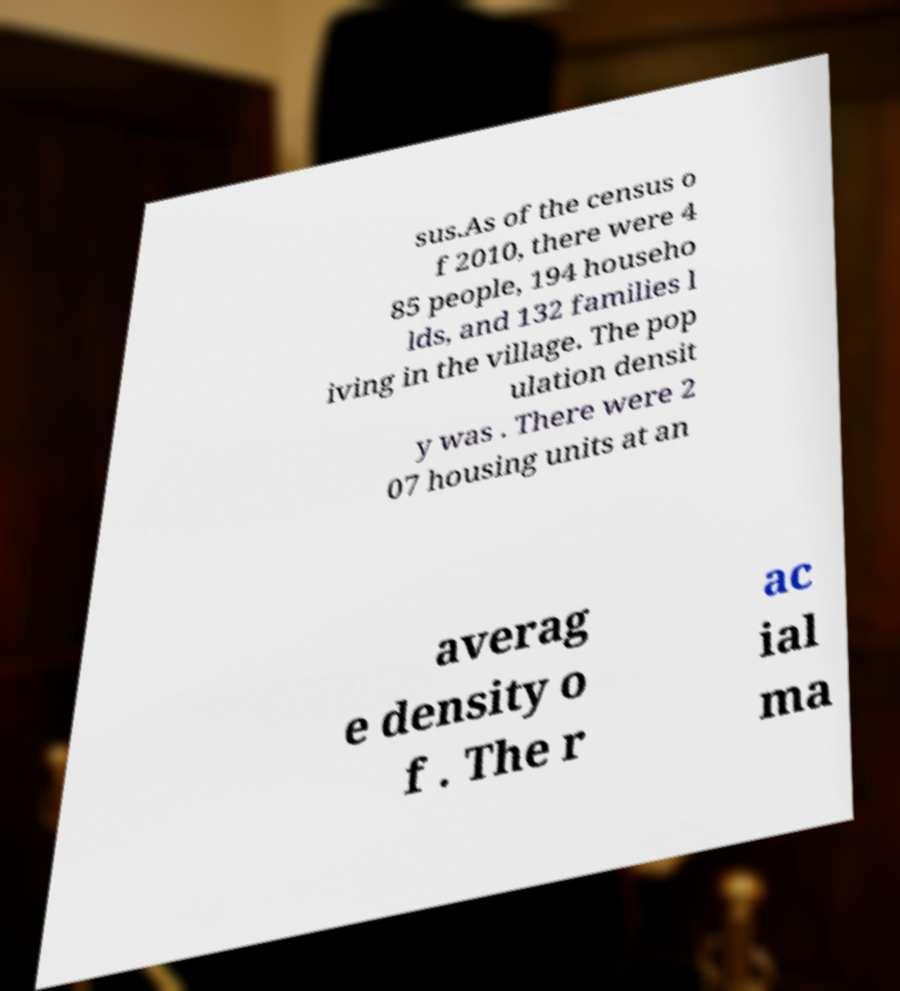I need the written content from this picture converted into text. Can you do that? sus.As of the census o f 2010, there were 4 85 people, 194 househo lds, and 132 families l iving in the village. The pop ulation densit y was . There were 2 07 housing units at an averag e density o f . The r ac ial ma 